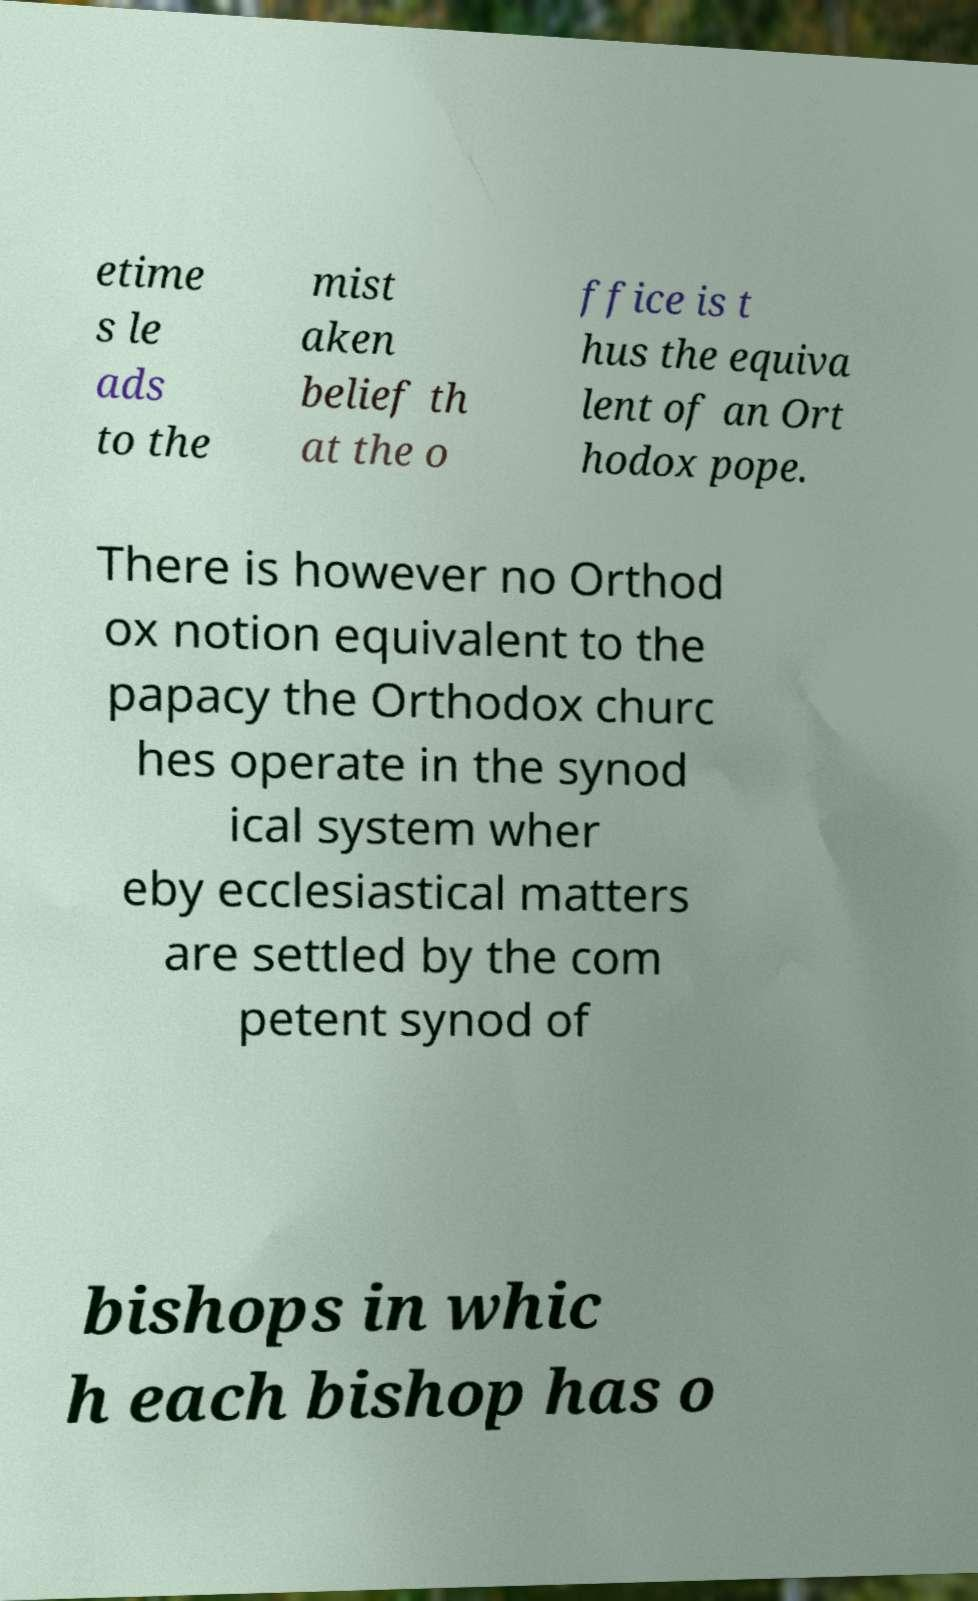What messages or text are displayed in this image? I need them in a readable, typed format. etime s le ads to the mist aken belief th at the o ffice is t hus the equiva lent of an Ort hodox pope. There is however no Orthod ox notion equivalent to the papacy the Orthodox churc hes operate in the synod ical system wher eby ecclesiastical matters are settled by the com petent synod of bishops in whic h each bishop has o 